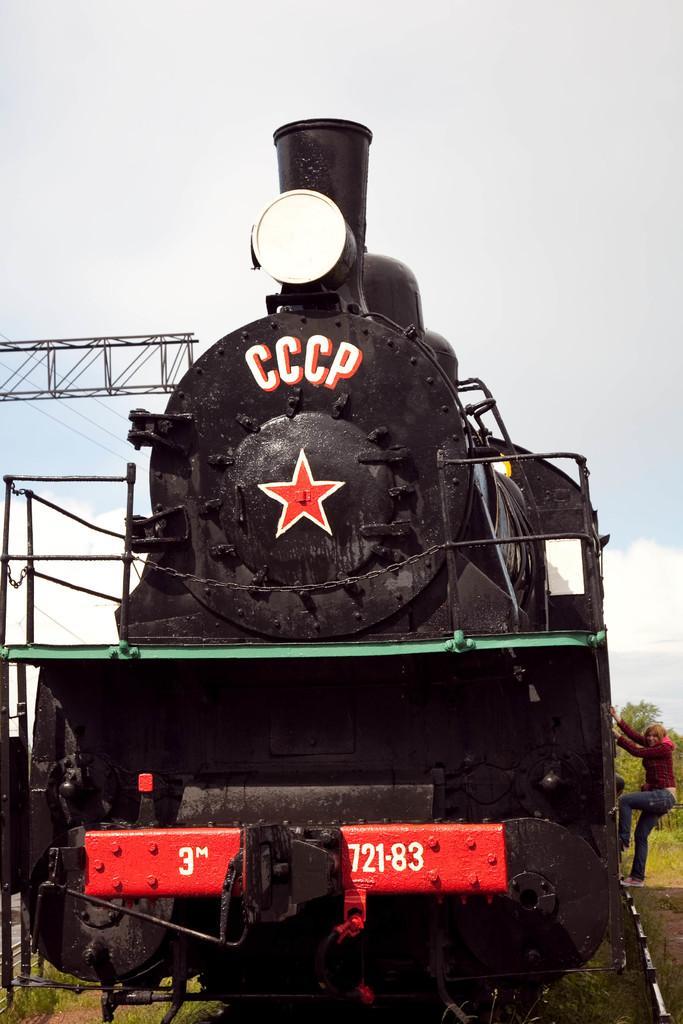In one or two sentences, can you explain what this image depicts? In this image I can see a railway engine which is black, red and white in color and I can see a person wearing red and blue colored dress is climbing the engine. In the background I can see few trees, few wires and the sky. 